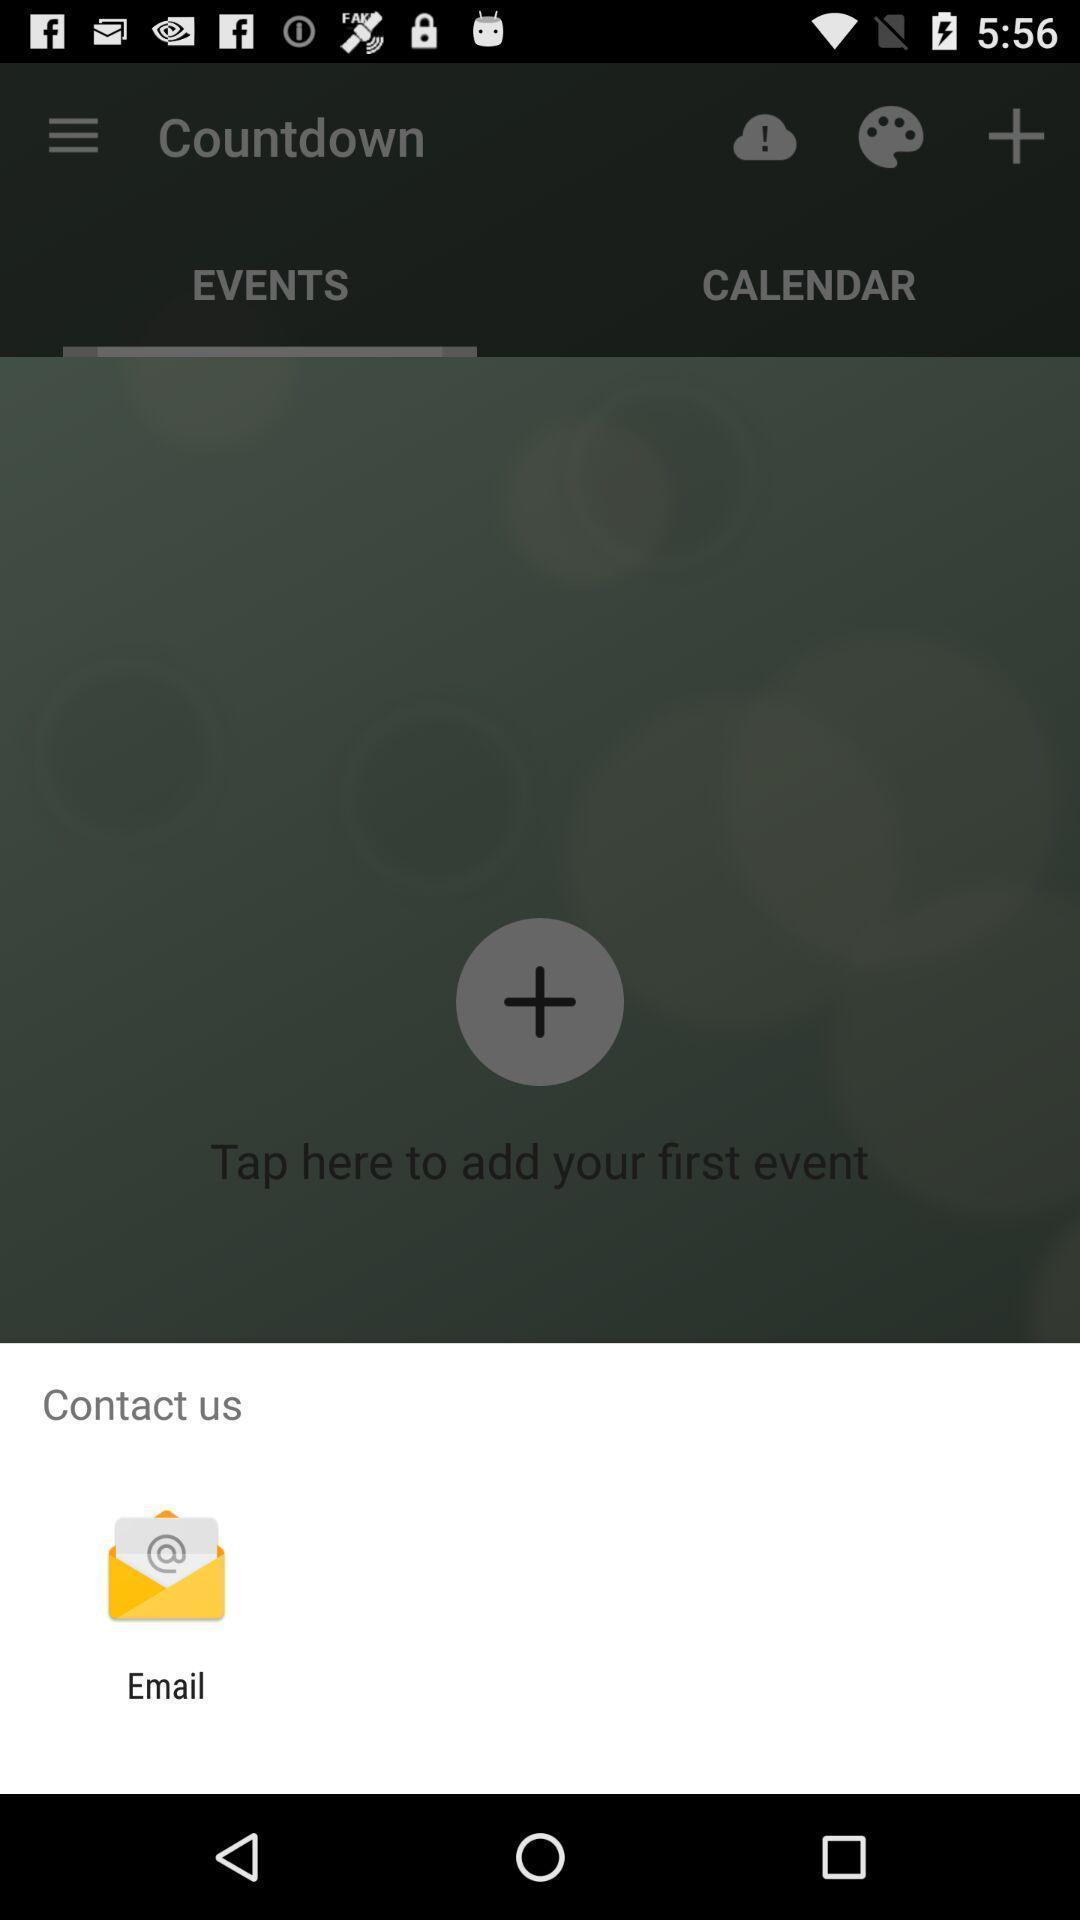What can you discern from this picture? Popup of application to contact the owners of application. 